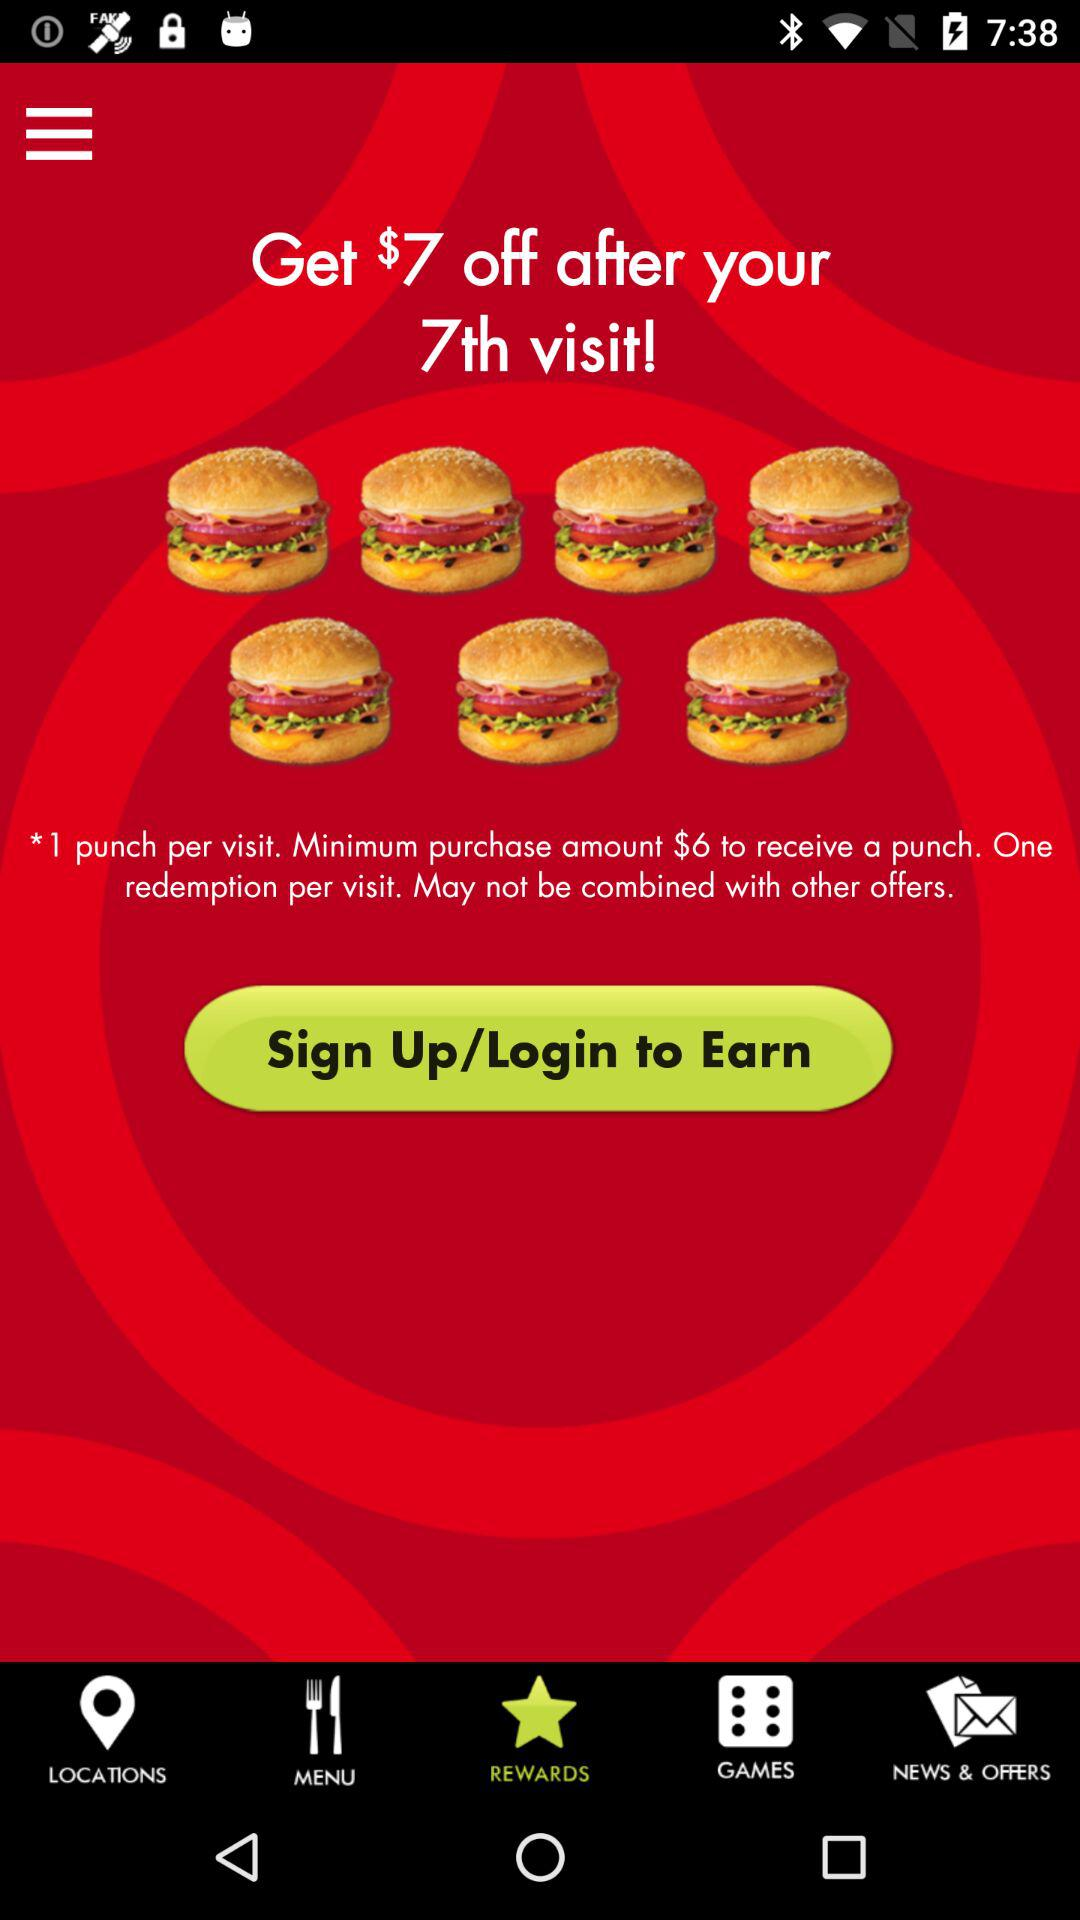How much money do I need to spend to get a punch on my card?
Answer the question using a single word or phrase. $6 